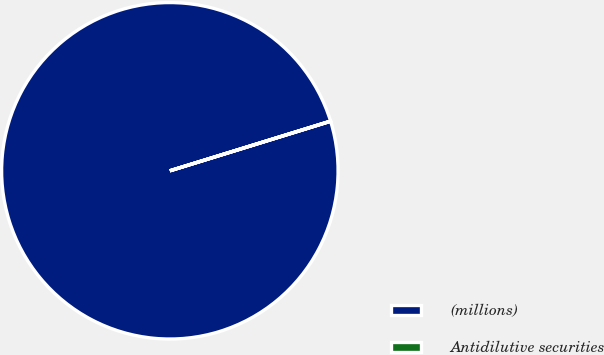Convert chart to OTSL. <chart><loc_0><loc_0><loc_500><loc_500><pie_chart><fcel>(millions)<fcel>Antidilutive securities<nl><fcel>99.98%<fcel>0.02%<nl></chart> 